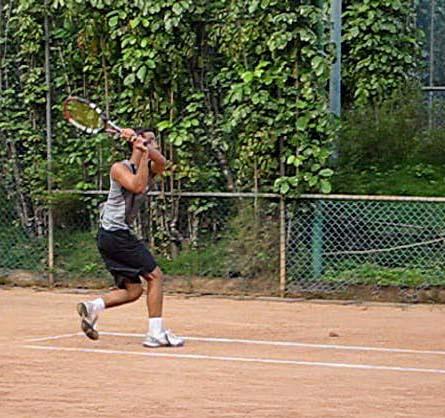What kind of pants is the person wearing?
Quick response, please. Shorts. What sport is being played?
Give a very brief answer. Tennis. What color is the man's shirt?
Write a very short answer. Gray. What is the sex of the player playing the sport?
Answer briefly. Male. 